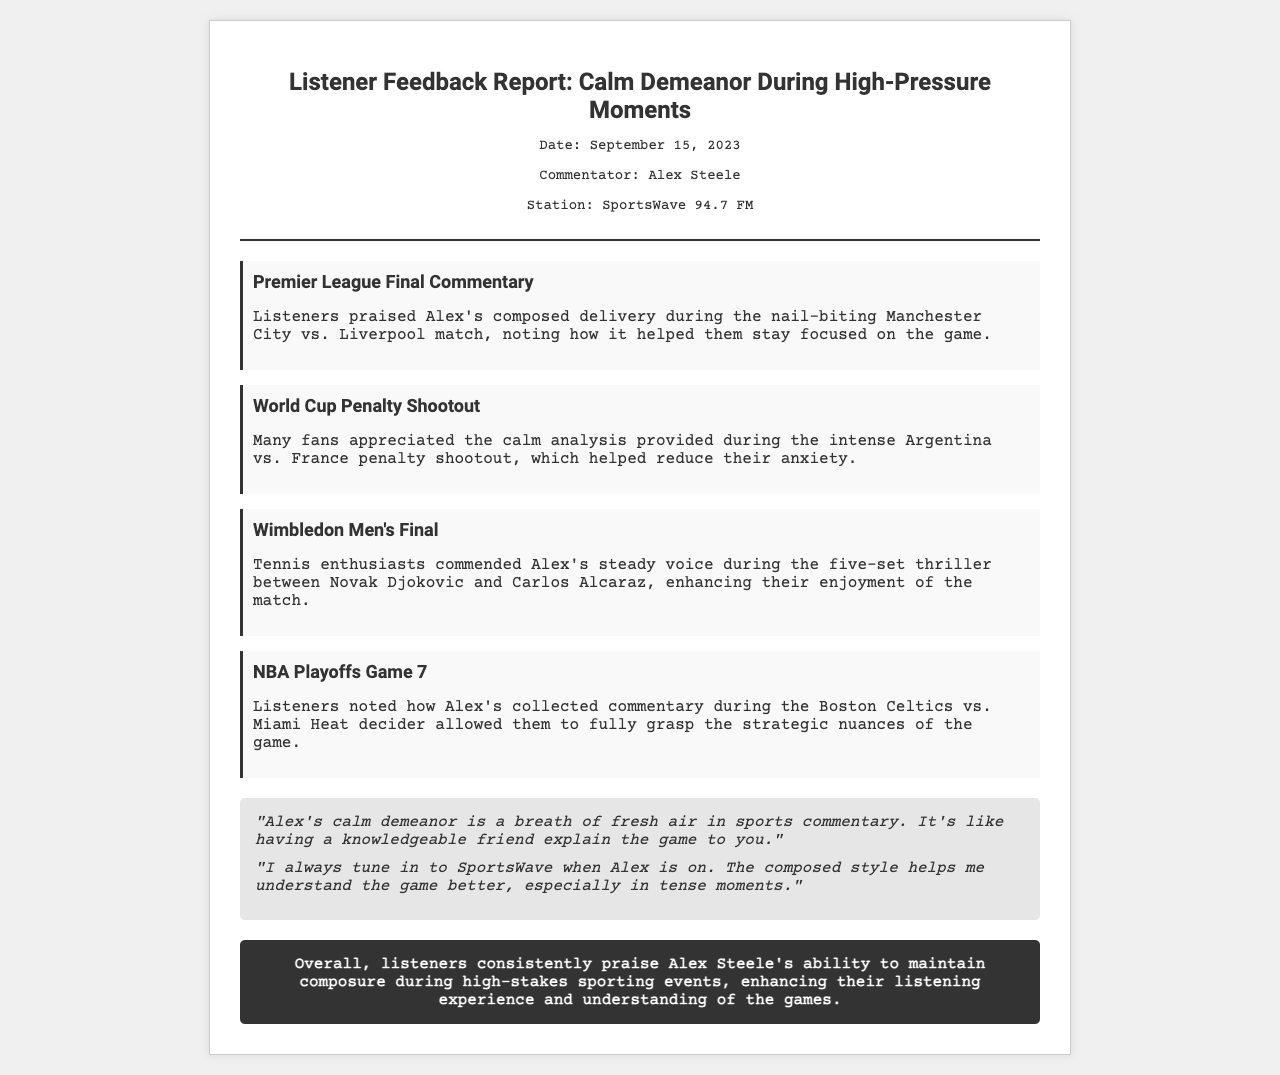What is the title of the report? The title of the report is stated at the top of the document, which reflects its content regarding feedback on calm demeanor during high-pressure moments.
Answer: Listener Feedback Report: Calm Demeanor During High-Pressure Moments Who is the commentator mentioned in the report? The commentator's name is provided in the meta-info section of the document, indicating who the report is about.
Answer: Alex Steele What date was the feedback report created? The date of the report is mentioned in the meta-info section, indicating when the feedback was summarized.
Answer: September 15, 2023 Which match received praise for Alex's composed delivery? This information can be found in the key points section, specifying a match where listeners appreciated the commentator's calm demeanor.
Answer: Manchester City vs. Liverpool What event did listeners appreciate Alex's commentary during the penalty shootout? The document lists a specific event in the key points section where Alex provided calm analysis during a tense moment.
Answer: Argentina vs. France What was the main feedback theme across various events? The overall sentiment and theme of the feedback is summarized in the conclusion, highlighting the main aspect listeners valued.
Answer: Composure In which championship was Alex's commentating praised? The document mentions multiple championships and matches; this refers to sports where feedback was given, found in the key points section.
Answer: Wimbledon What feeling did listeners express about Alex's calm demeanor? The quotes section provides direct feedback from listeners about how they felt regarding the commentator's style.
Answer: Breath of fresh air 